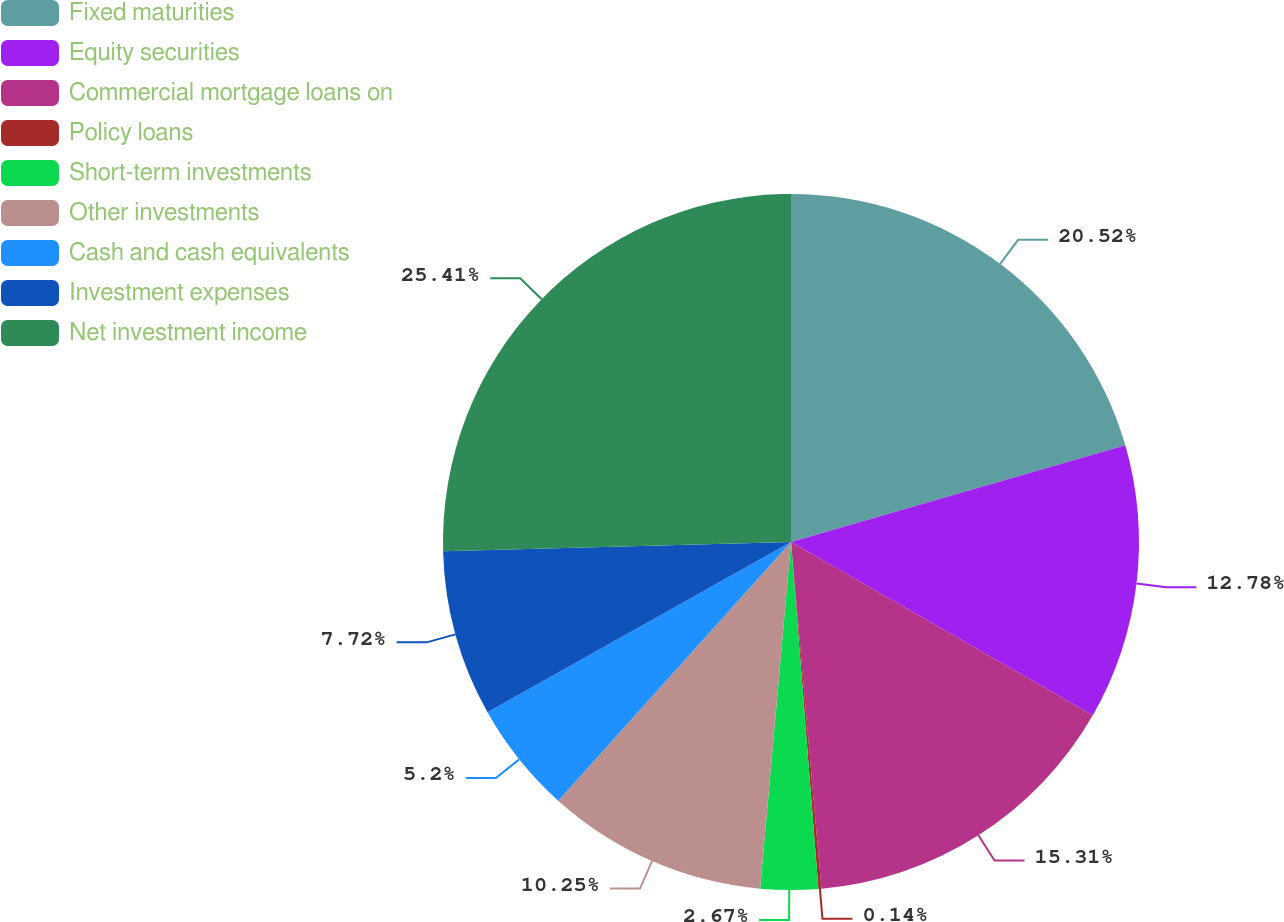Convert chart to OTSL. <chart><loc_0><loc_0><loc_500><loc_500><pie_chart><fcel>Fixed maturities<fcel>Equity securities<fcel>Commercial mortgage loans on<fcel>Policy loans<fcel>Short-term investments<fcel>Other investments<fcel>Cash and cash equivalents<fcel>Investment expenses<fcel>Net investment income<nl><fcel>20.52%<fcel>12.78%<fcel>15.31%<fcel>0.14%<fcel>2.67%<fcel>10.25%<fcel>5.2%<fcel>7.72%<fcel>25.42%<nl></chart> 